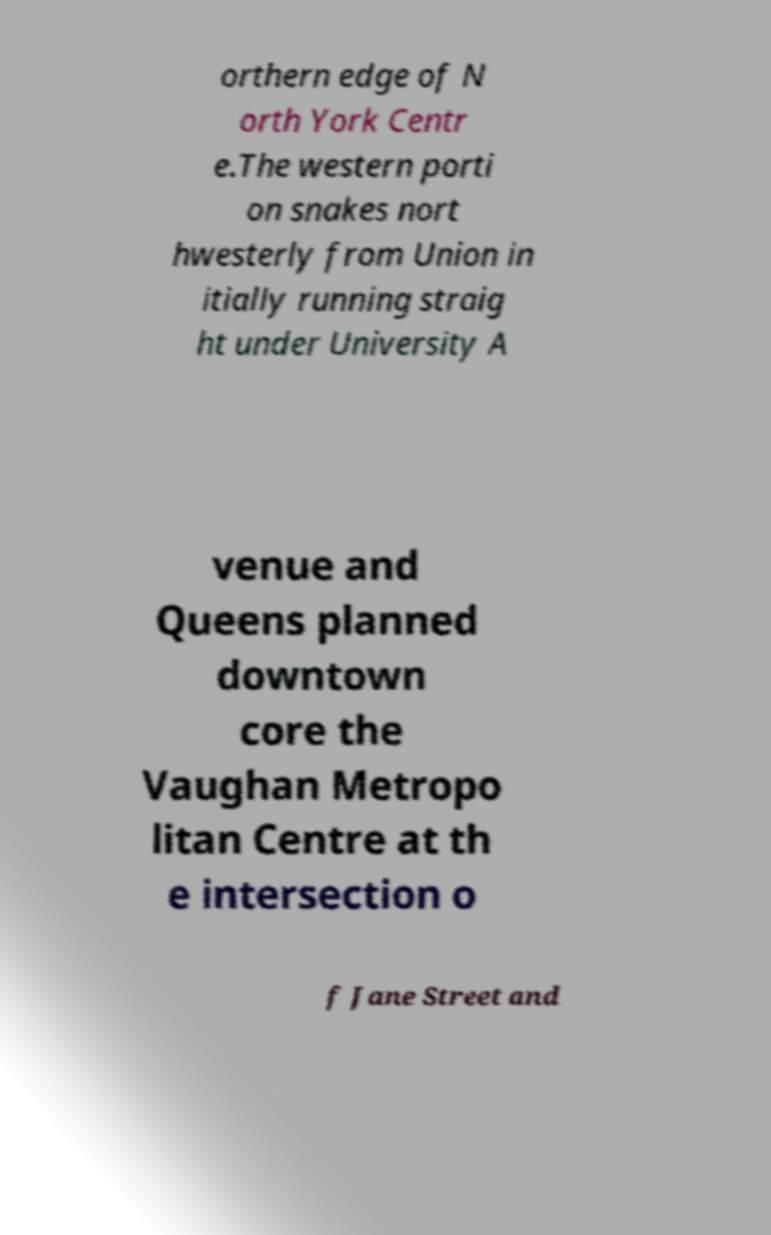What messages or text are displayed in this image? I need them in a readable, typed format. orthern edge of N orth York Centr e.The western porti on snakes nort hwesterly from Union in itially running straig ht under University A venue and Queens planned downtown core the Vaughan Metropo litan Centre at th e intersection o f Jane Street and 